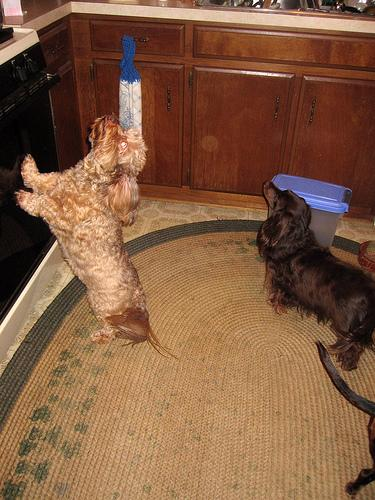Explain the appearance of the rug and its predominant colors. The rug on the kitchen floor is brown and grey, with a green and tan color scheme. Mention the type of floor and the item present on it. The kitchen floor is linoleum and has a green and tan rug with a dog bowl on it. Provide details about the oven and its location in the kitchen. A white and black oven, possibly a range, is located on the left side of the kitchen, near the cabinets. State the material of the sink and its position in the kitchen. A stainless steel sink is present on the right side of the kitchen, close to the cabinets. Identify the two main animals in the image along with their color and position. There is a small light brown dog near the left side and a small dark brown dog on the right side, both standing on a kitchen rug. Describe the features of the kitchen cabinet and its hardware. The kitchen cabinets are made of dark brown wood with metal handles and have a wooden drawer face. Describe the container and its lid that are visible on the kitchen floor. A blue and clear Tupperware container with a light blue lid is lying on the kitchen floor. Describe the scene of the image involving the two dogs and the rug. Two dogs, one light brown and one dark brown, are standing on a green and tan kitchen rug, with one dog placing its paw on the black stove. What is the action of the tan colored dog and where is it placed in the kitchen? The tan dog with curly hair is placing its front paw on the black stove, which is located at the left side of the kitchen. What type of towel is hanging from the cabinet and what colors does it have? A blue and white decorative kitchen towel is hanging from the cabinet. 